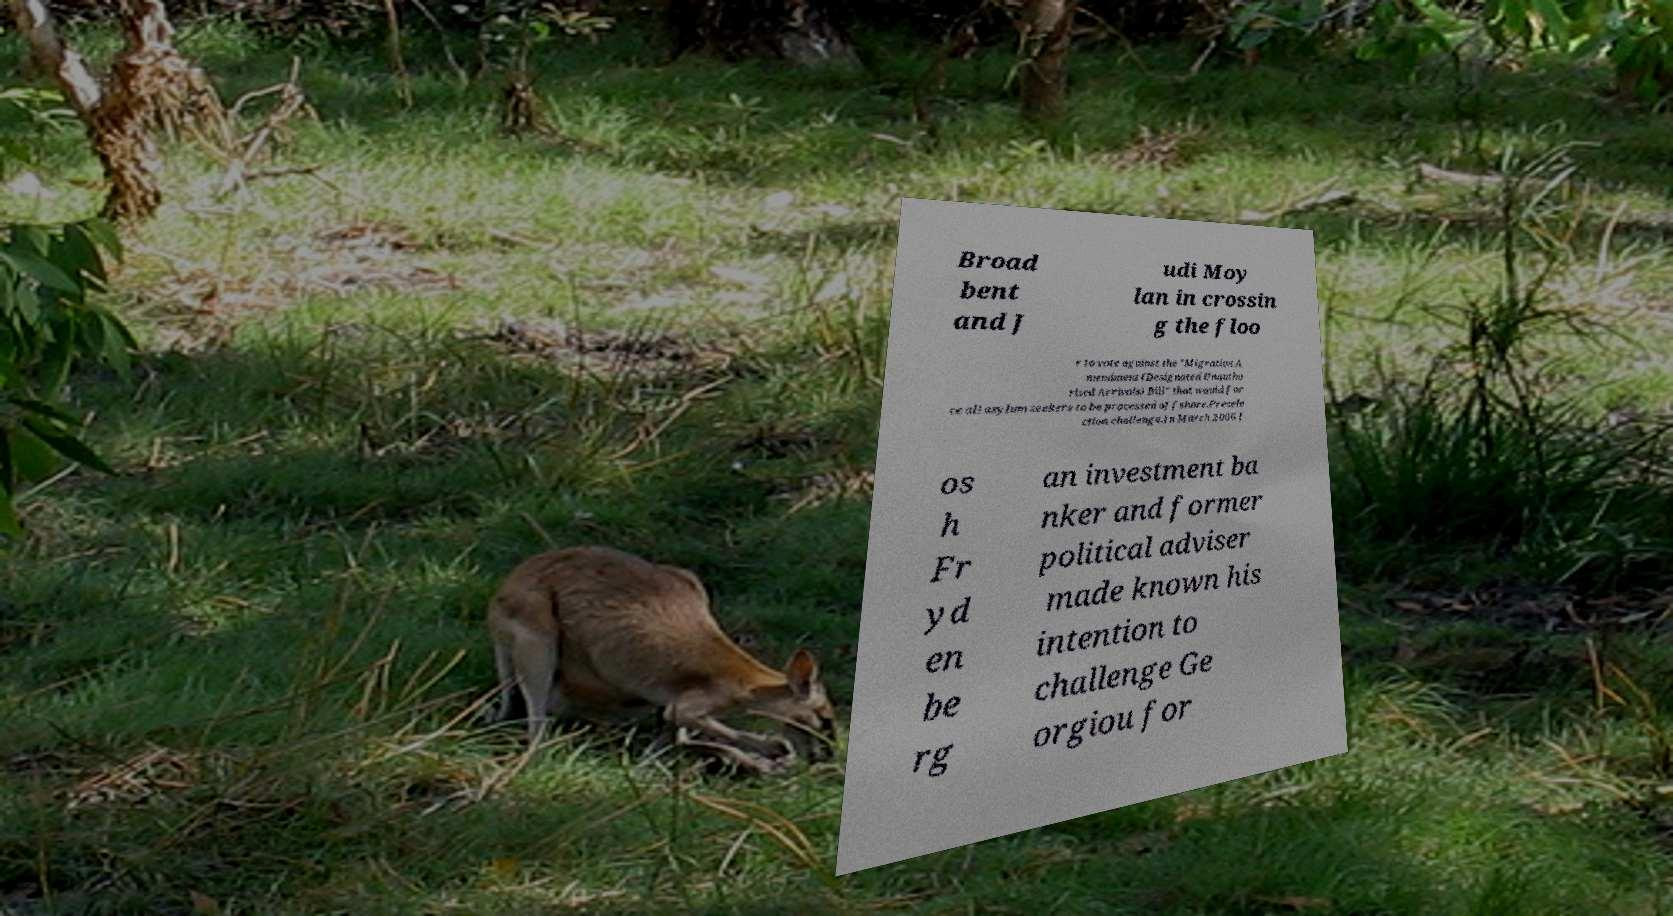For documentation purposes, I need the text within this image transcribed. Could you provide that? Broad bent and J udi Moy lan in crossin g the floo r to vote against the "Migration A mendment (Designated Unautho rised Arrivals) Bill" that would for ce all asylum seekers to be processed offshore.Presele ction challenge.In March 2006 J os h Fr yd en be rg an investment ba nker and former political adviser made known his intention to challenge Ge orgiou for 